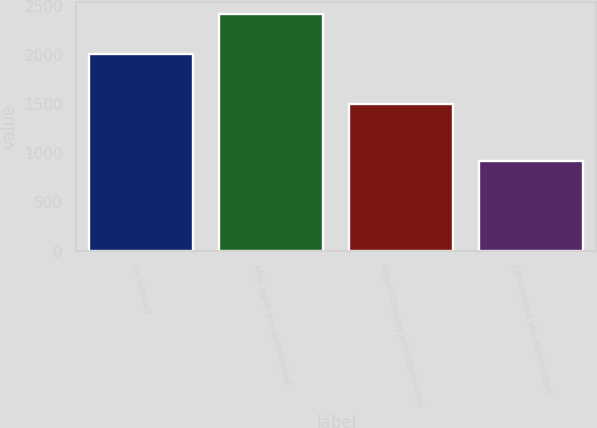<chart> <loc_0><loc_0><loc_500><loc_500><bar_chart><fcel>(In millions)<fcel>Aflac Japan yen-denominated<fcel>Parent Company yen-denominated<fcel>Consolidated yen-denominated<nl><fcel>2007<fcel>2415<fcel>1496<fcel>919<nl></chart> 